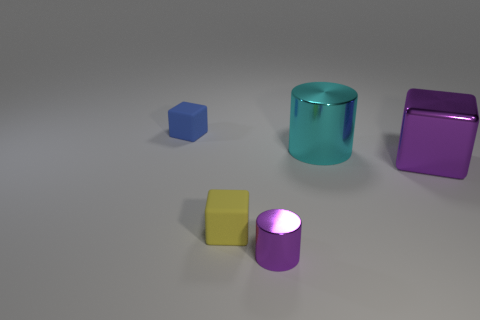Add 4 purple metallic blocks. How many objects exist? 9 Subtract all cylinders. How many objects are left? 3 Subtract all cyan things. Subtract all small cylinders. How many objects are left? 3 Add 5 yellow objects. How many yellow objects are left? 6 Add 5 blue matte blocks. How many blue matte blocks exist? 6 Subtract 0 cyan spheres. How many objects are left? 5 